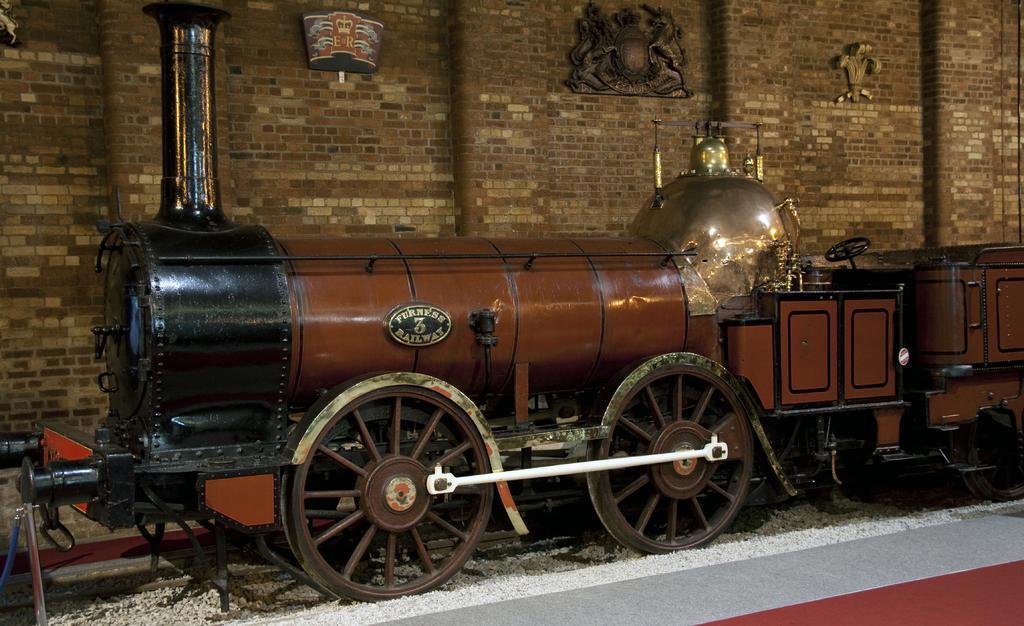Can you describe this image briefly? In the image there is a toy locomotive. And also there are white color objects on the ground. In the background there is a wall with pillars and frames. 